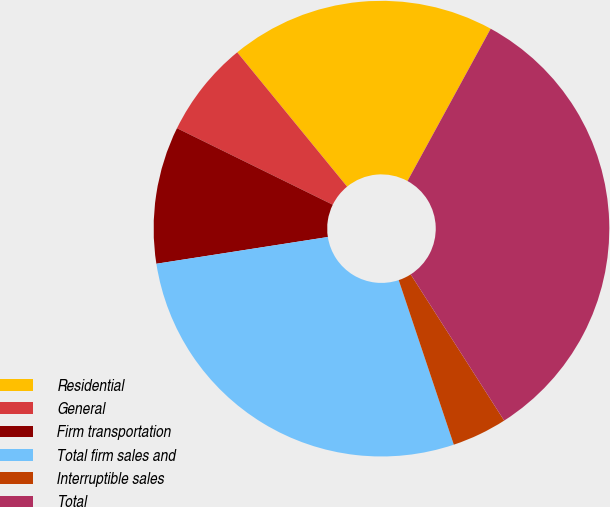Convert chart. <chart><loc_0><loc_0><loc_500><loc_500><pie_chart><fcel>Residential<fcel>General<fcel>Firm transportation<fcel>Total firm sales and<fcel>Interruptible sales<fcel>Total<nl><fcel>18.87%<fcel>6.82%<fcel>9.73%<fcel>27.68%<fcel>3.91%<fcel>32.99%<nl></chart> 